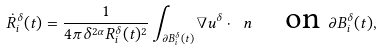Convert formula to latex. <formula><loc_0><loc_0><loc_500><loc_500>\dot { R } _ { i } ^ { \delta } ( t ) = \frac { 1 } { 4 \pi \delta ^ { 2 \alpha } R _ { i } ^ { \delta } ( t ) ^ { 2 } } \int _ { \partial B _ { i } ^ { \delta } ( t ) } \nabla u ^ { \delta } \cdot \ n \quad \text {on } \partial B _ { i } ^ { \delta } ( t ) ,</formula> 